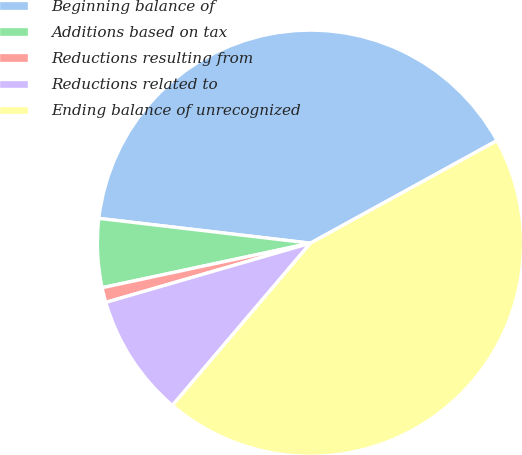Convert chart to OTSL. <chart><loc_0><loc_0><loc_500><loc_500><pie_chart><fcel>Beginning balance of<fcel>Additions based on tax<fcel>Reductions resulting from<fcel>Reductions related to<fcel>Ending balance of unrecognized<nl><fcel>40.14%<fcel>5.21%<fcel>1.13%<fcel>9.3%<fcel>44.22%<nl></chart> 